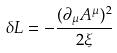Convert formula to latex. <formula><loc_0><loc_0><loc_500><loc_500>\delta L = - \frac { ( \partial _ { \mu } A ^ { \mu } ) ^ { 2 } } { 2 \xi }</formula> 